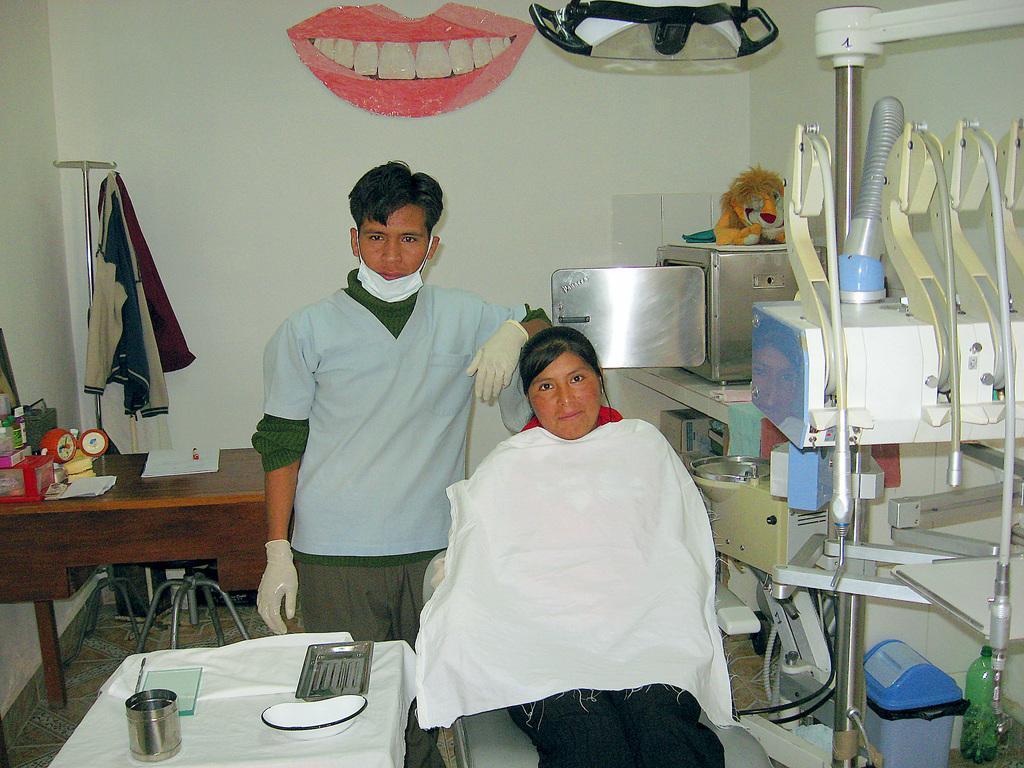Please provide a concise description of this image. This picture shows an inner view of a hospital room. So many objects are on the surface, the wall is painted with a mouth picture, shirts hanging on a hanger, one object hanging on a wall, two tables, one table is covered with white cloth and so many different objects are on these tables. One woman sitting in a chair and one man is standing. 